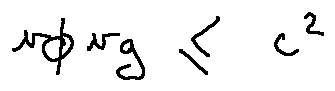Convert formula to latex. <formula><loc_0><loc_0><loc_500><loc_500>v _ { \phi } v _ { g } \leq c ^ { 2 }</formula> 